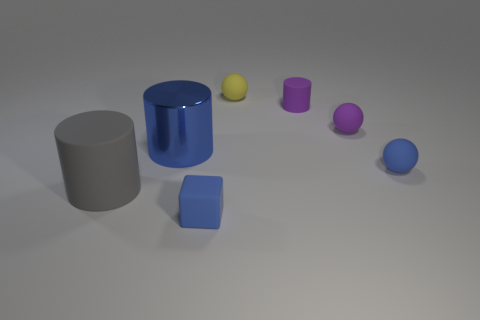The small sphere behind the small purple matte object to the right of the purple rubber cylinder is what color? yellow 